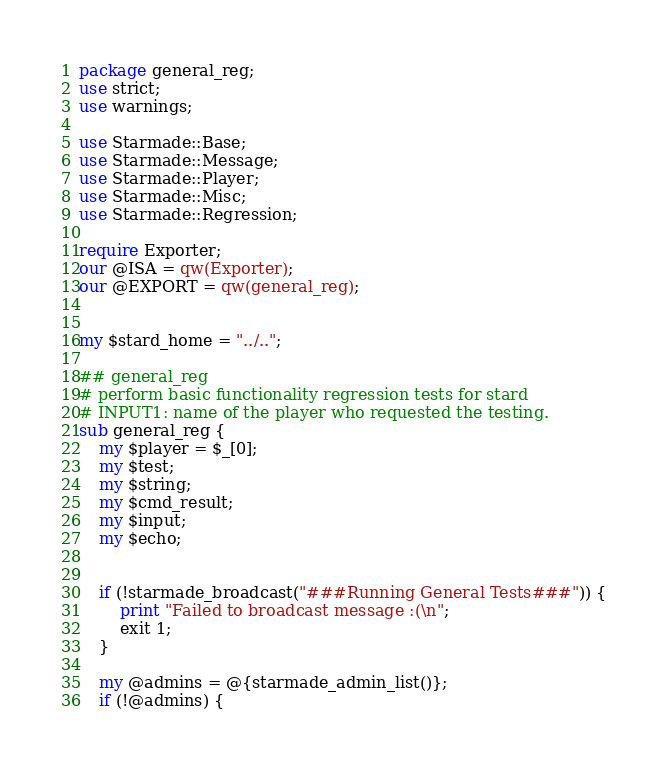Convert code to text. <code><loc_0><loc_0><loc_500><loc_500><_Perl_>
package general_reg;
use strict;
use warnings;

use Starmade::Base;
use Starmade::Message;
use Starmade::Player;
use Starmade::Misc;
use Starmade::Regression;

require Exporter;
our @ISA = qw(Exporter);
our @EXPORT = qw(general_reg);


my $stard_home = "../..";

## general_reg
# perform basic functionality regression tests for stard
# INPUT1: name of the player who requested the testing.
sub general_reg {
	my $player = $_[0];
	my $test;
	my $string;
	my $cmd_result;
	my $input;
	my $echo;


	if (!starmade_broadcast("###Running General Tests###")) {
		print "Failed to broadcast message :(\n";
		exit 1;
	}

	my @admins = @{starmade_admin_list()};
	if (!@admins) {</code> 